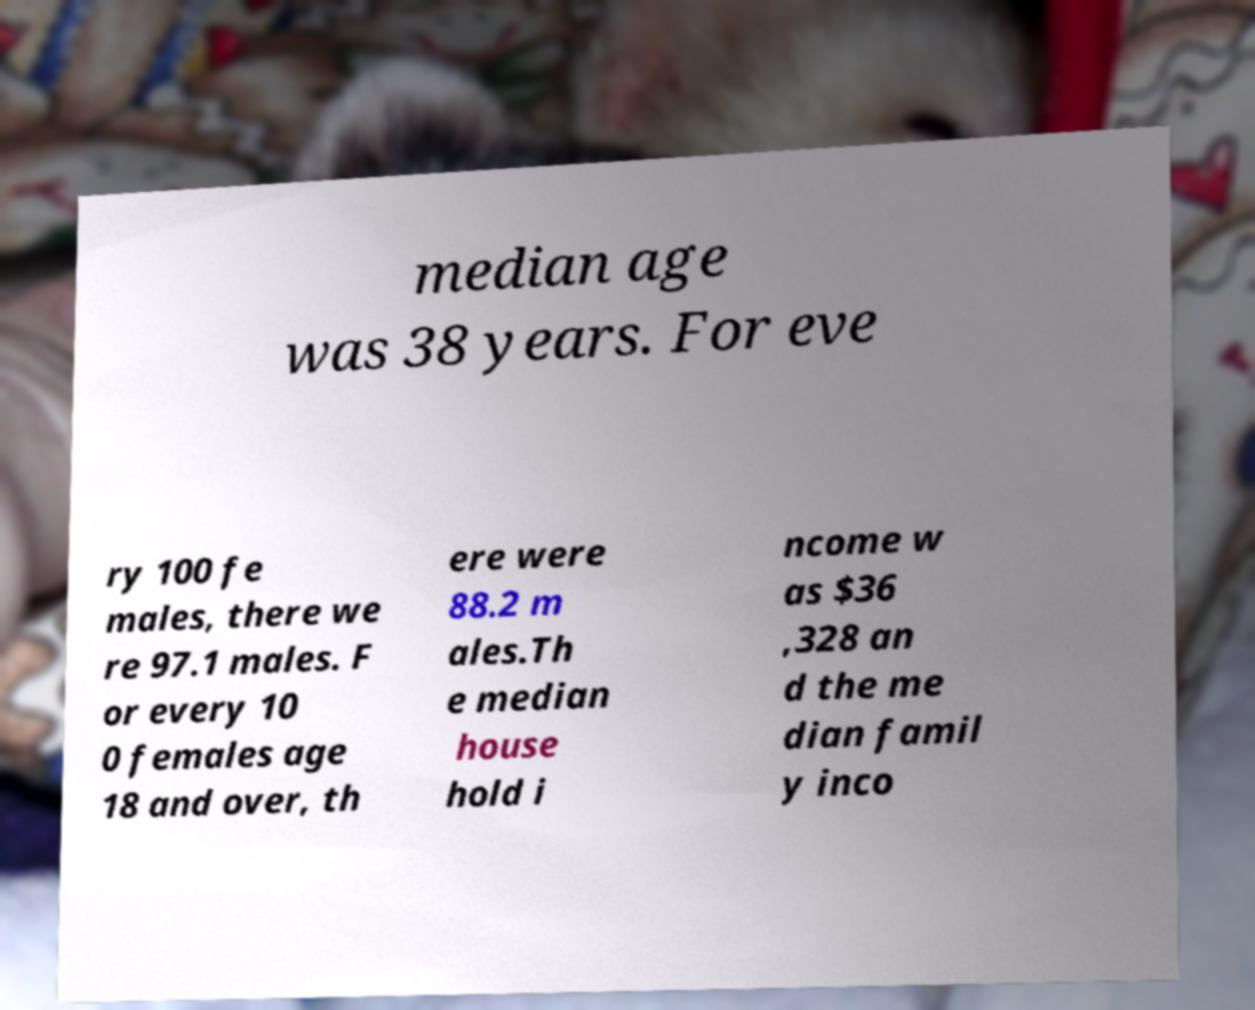Could you assist in decoding the text presented in this image and type it out clearly? median age was 38 years. For eve ry 100 fe males, there we re 97.1 males. F or every 10 0 females age 18 and over, th ere were 88.2 m ales.Th e median house hold i ncome w as $36 ,328 an d the me dian famil y inco 